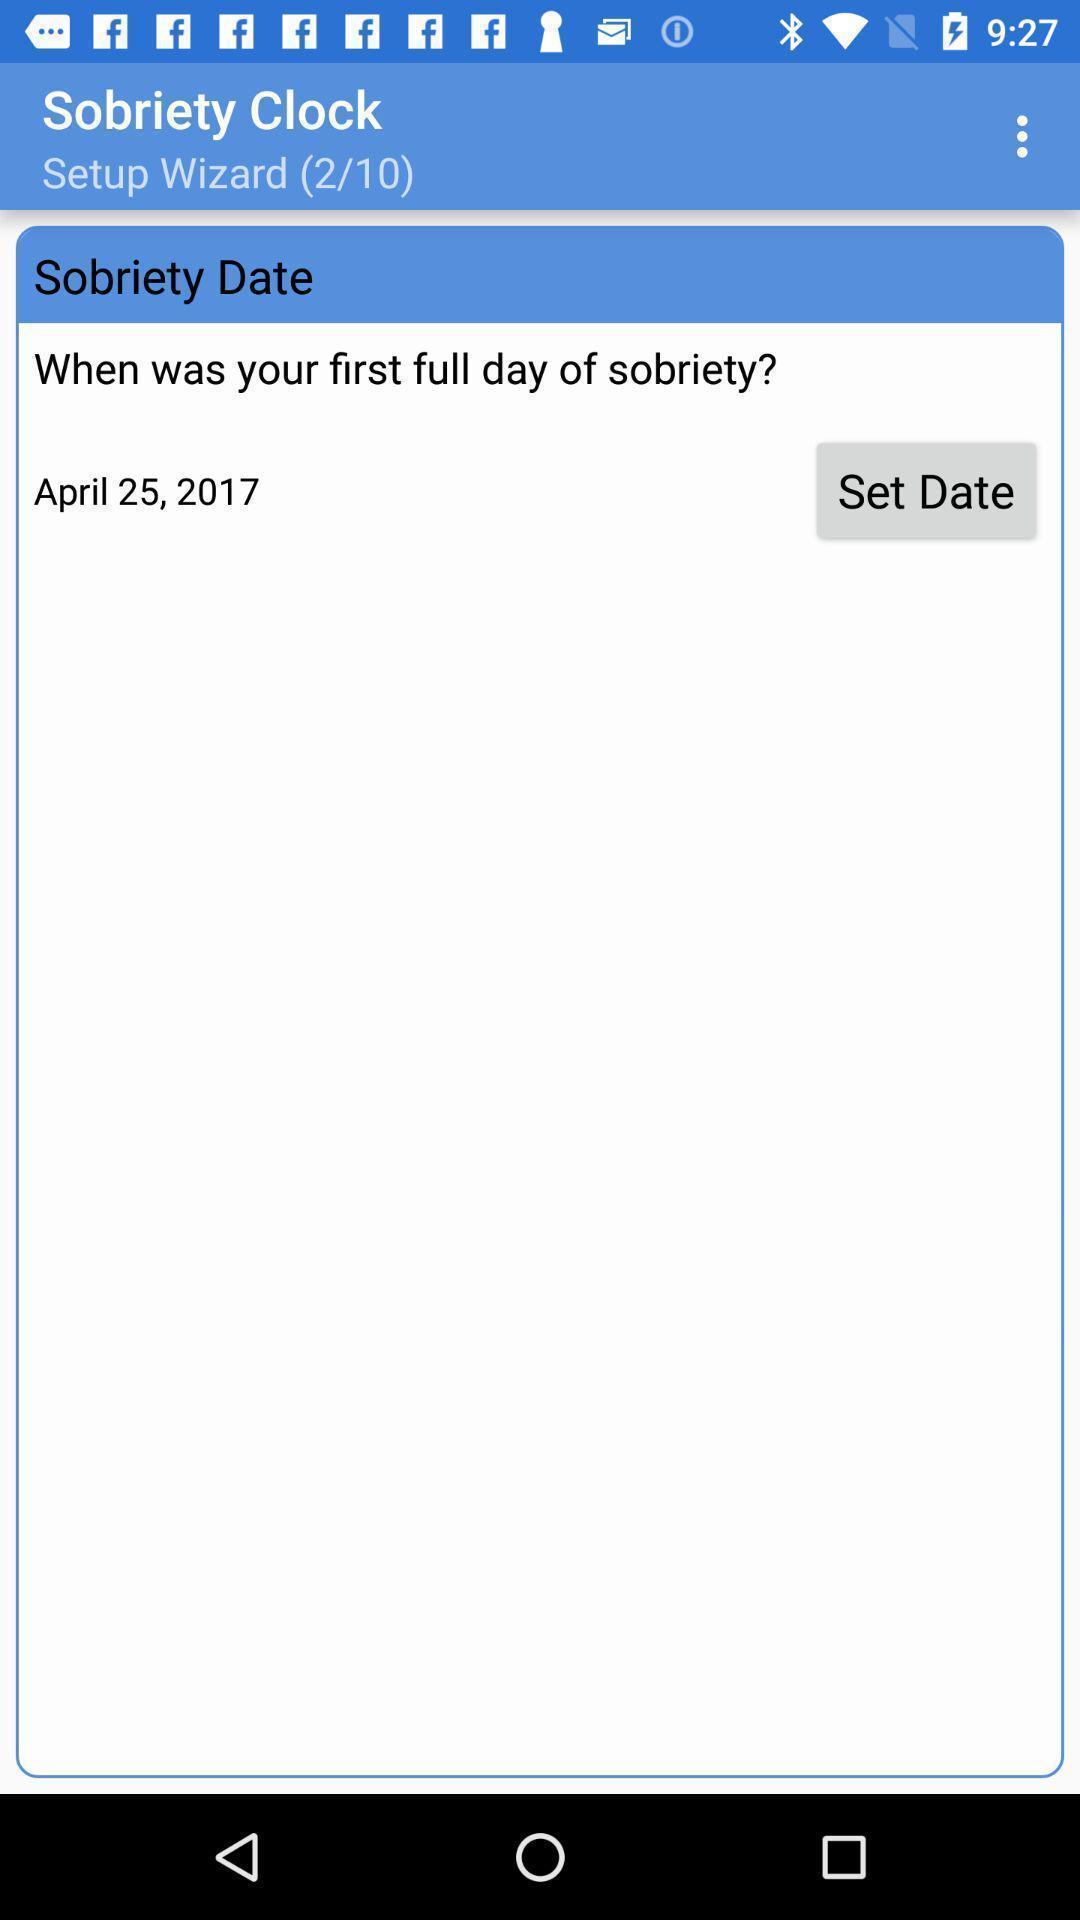Explain what's happening in this screen capture. Set date in sobriety date. 